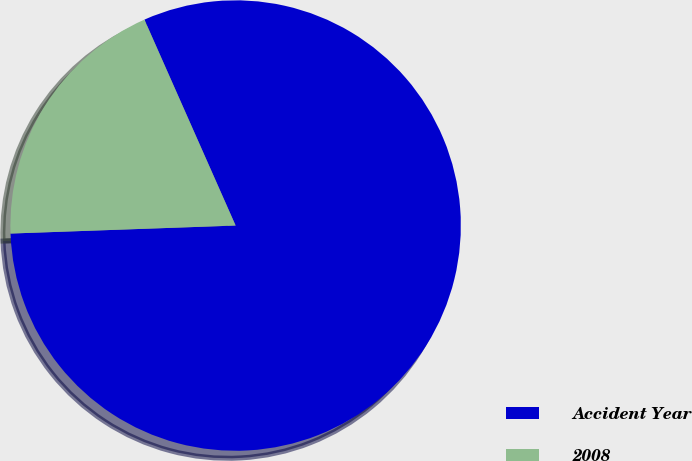Convert chart. <chart><loc_0><loc_0><loc_500><loc_500><pie_chart><fcel>Accident Year<fcel>2008<nl><fcel>81.07%<fcel>18.93%<nl></chart> 